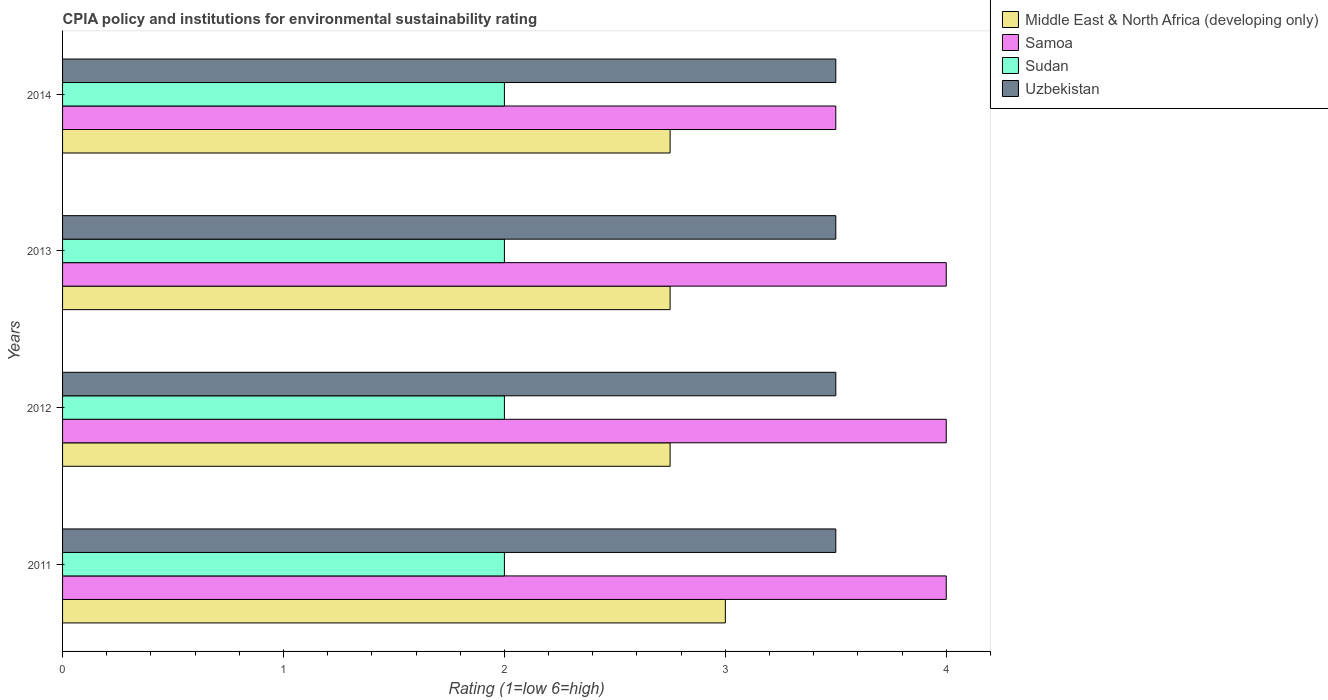How many different coloured bars are there?
Give a very brief answer. 4. In how many cases, is the number of bars for a given year not equal to the number of legend labels?
Offer a very short reply. 0. What is the CPIA rating in Samoa in 2014?
Provide a succinct answer. 3.5. Across all years, what is the maximum CPIA rating in Samoa?
Your response must be concise. 4. Across all years, what is the minimum CPIA rating in Middle East & North Africa (developing only)?
Provide a short and direct response. 2.75. In which year was the CPIA rating in Samoa maximum?
Offer a very short reply. 2011. In which year was the CPIA rating in Samoa minimum?
Provide a short and direct response. 2014. What is the total CPIA rating in Samoa in the graph?
Your response must be concise. 15.5. In the year 2014, what is the difference between the CPIA rating in Uzbekistan and CPIA rating in Middle East & North Africa (developing only)?
Your answer should be very brief. 0.75. What is the ratio of the CPIA rating in Middle East & North Africa (developing only) in 2012 to that in 2013?
Keep it short and to the point. 1. Is the difference between the CPIA rating in Uzbekistan in 2013 and 2014 greater than the difference between the CPIA rating in Middle East & North Africa (developing only) in 2013 and 2014?
Your answer should be very brief. No. In how many years, is the CPIA rating in Middle East & North Africa (developing only) greater than the average CPIA rating in Middle East & North Africa (developing only) taken over all years?
Offer a terse response. 1. Is the sum of the CPIA rating in Uzbekistan in 2011 and 2014 greater than the maximum CPIA rating in Samoa across all years?
Keep it short and to the point. Yes. What does the 1st bar from the top in 2012 represents?
Keep it short and to the point. Uzbekistan. What does the 2nd bar from the bottom in 2011 represents?
Give a very brief answer. Samoa. Are all the bars in the graph horizontal?
Offer a very short reply. Yes. What is the difference between two consecutive major ticks on the X-axis?
Make the answer very short. 1. Does the graph contain any zero values?
Provide a succinct answer. No. Does the graph contain grids?
Provide a short and direct response. No. How many legend labels are there?
Give a very brief answer. 4. What is the title of the graph?
Ensure brevity in your answer.  CPIA policy and institutions for environmental sustainability rating. Does "Singapore" appear as one of the legend labels in the graph?
Your response must be concise. No. What is the label or title of the X-axis?
Your answer should be compact. Rating (1=low 6=high). What is the label or title of the Y-axis?
Your answer should be compact. Years. What is the Rating (1=low 6=high) of Middle East & North Africa (developing only) in 2011?
Give a very brief answer. 3. What is the Rating (1=low 6=high) in Uzbekistan in 2011?
Ensure brevity in your answer.  3.5. What is the Rating (1=low 6=high) of Middle East & North Africa (developing only) in 2012?
Provide a succinct answer. 2.75. What is the Rating (1=low 6=high) of Samoa in 2012?
Offer a very short reply. 4. What is the Rating (1=low 6=high) of Sudan in 2012?
Your answer should be very brief. 2. What is the Rating (1=low 6=high) of Uzbekistan in 2012?
Your answer should be compact. 3.5. What is the Rating (1=low 6=high) in Middle East & North Africa (developing only) in 2013?
Keep it short and to the point. 2.75. What is the Rating (1=low 6=high) of Uzbekistan in 2013?
Your response must be concise. 3.5. What is the Rating (1=low 6=high) of Middle East & North Africa (developing only) in 2014?
Give a very brief answer. 2.75. What is the Rating (1=low 6=high) of Samoa in 2014?
Ensure brevity in your answer.  3.5. What is the Rating (1=low 6=high) in Sudan in 2014?
Ensure brevity in your answer.  2. Across all years, what is the maximum Rating (1=low 6=high) of Samoa?
Your answer should be very brief. 4. Across all years, what is the maximum Rating (1=low 6=high) in Sudan?
Your response must be concise. 2. Across all years, what is the minimum Rating (1=low 6=high) in Middle East & North Africa (developing only)?
Your answer should be compact. 2.75. Across all years, what is the minimum Rating (1=low 6=high) in Sudan?
Your answer should be very brief. 2. What is the total Rating (1=low 6=high) of Middle East & North Africa (developing only) in the graph?
Ensure brevity in your answer.  11.25. What is the total Rating (1=low 6=high) of Sudan in the graph?
Offer a very short reply. 8. What is the total Rating (1=low 6=high) of Uzbekistan in the graph?
Your answer should be very brief. 14. What is the difference between the Rating (1=low 6=high) of Middle East & North Africa (developing only) in 2011 and that in 2012?
Ensure brevity in your answer.  0.25. What is the difference between the Rating (1=low 6=high) in Sudan in 2011 and that in 2012?
Your response must be concise. 0. What is the difference between the Rating (1=low 6=high) of Middle East & North Africa (developing only) in 2011 and that in 2013?
Provide a short and direct response. 0.25. What is the difference between the Rating (1=low 6=high) in Samoa in 2011 and that in 2013?
Offer a very short reply. 0. What is the difference between the Rating (1=low 6=high) of Middle East & North Africa (developing only) in 2011 and that in 2014?
Offer a terse response. 0.25. What is the difference between the Rating (1=low 6=high) of Samoa in 2011 and that in 2014?
Provide a short and direct response. 0.5. What is the difference between the Rating (1=low 6=high) in Sudan in 2011 and that in 2014?
Give a very brief answer. 0. What is the difference between the Rating (1=low 6=high) of Uzbekistan in 2011 and that in 2014?
Give a very brief answer. 0. What is the difference between the Rating (1=low 6=high) in Middle East & North Africa (developing only) in 2012 and that in 2013?
Keep it short and to the point. 0. What is the difference between the Rating (1=low 6=high) in Samoa in 2012 and that in 2013?
Provide a succinct answer. 0. What is the difference between the Rating (1=low 6=high) in Sudan in 2012 and that in 2013?
Provide a succinct answer. 0. What is the difference between the Rating (1=low 6=high) of Middle East & North Africa (developing only) in 2012 and that in 2014?
Offer a very short reply. 0. What is the difference between the Rating (1=low 6=high) in Samoa in 2012 and that in 2014?
Offer a terse response. 0.5. What is the difference between the Rating (1=low 6=high) in Sudan in 2012 and that in 2014?
Your response must be concise. 0. What is the difference between the Rating (1=low 6=high) of Samoa in 2013 and that in 2014?
Your answer should be very brief. 0.5. What is the difference between the Rating (1=low 6=high) of Middle East & North Africa (developing only) in 2011 and the Rating (1=low 6=high) of Samoa in 2012?
Provide a short and direct response. -1. What is the difference between the Rating (1=low 6=high) in Middle East & North Africa (developing only) in 2011 and the Rating (1=low 6=high) in Uzbekistan in 2012?
Your response must be concise. -0.5. What is the difference between the Rating (1=low 6=high) of Sudan in 2011 and the Rating (1=low 6=high) of Uzbekistan in 2012?
Make the answer very short. -1.5. What is the difference between the Rating (1=low 6=high) in Middle East & North Africa (developing only) in 2011 and the Rating (1=low 6=high) in Samoa in 2013?
Offer a very short reply. -1. What is the difference between the Rating (1=low 6=high) of Samoa in 2011 and the Rating (1=low 6=high) of Sudan in 2013?
Provide a short and direct response. 2. What is the difference between the Rating (1=low 6=high) in Sudan in 2011 and the Rating (1=low 6=high) in Uzbekistan in 2013?
Make the answer very short. -1.5. What is the difference between the Rating (1=low 6=high) of Middle East & North Africa (developing only) in 2011 and the Rating (1=low 6=high) of Uzbekistan in 2014?
Your answer should be compact. -0.5. What is the difference between the Rating (1=low 6=high) of Samoa in 2011 and the Rating (1=low 6=high) of Sudan in 2014?
Keep it short and to the point. 2. What is the difference between the Rating (1=low 6=high) of Samoa in 2011 and the Rating (1=low 6=high) of Uzbekistan in 2014?
Make the answer very short. 0.5. What is the difference between the Rating (1=low 6=high) in Sudan in 2011 and the Rating (1=low 6=high) in Uzbekistan in 2014?
Your answer should be very brief. -1.5. What is the difference between the Rating (1=low 6=high) in Middle East & North Africa (developing only) in 2012 and the Rating (1=low 6=high) in Samoa in 2013?
Your response must be concise. -1.25. What is the difference between the Rating (1=low 6=high) of Middle East & North Africa (developing only) in 2012 and the Rating (1=low 6=high) of Uzbekistan in 2013?
Your answer should be compact. -0.75. What is the difference between the Rating (1=low 6=high) in Samoa in 2012 and the Rating (1=low 6=high) in Sudan in 2013?
Provide a succinct answer. 2. What is the difference between the Rating (1=low 6=high) of Middle East & North Africa (developing only) in 2012 and the Rating (1=low 6=high) of Samoa in 2014?
Your answer should be very brief. -0.75. What is the difference between the Rating (1=low 6=high) in Middle East & North Africa (developing only) in 2012 and the Rating (1=low 6=high) in Sudan in 2014?
Your answer should be very brief. 0.75. What is the difference between the Rating (1=low 6=high) in Middle East & North Africa (developing only) in 2012 and the Rating (1=low 6=high) in Uzbekistan in 2014?
Your answer should be very brief. -0.75. What is the difference between the Rating (1=low 6=high) in Sudan in 2012 and the Rating (1=low 6=high) in Uzbekistan in 2014?
Keep it short and to the point. -1.5. What is the difference between the Rating (1=low 6=high) of Middle East & North Africa (developing only) in 2013 and the Rating (1=low 6=high) of Samoa in 2014?
Offer a terse response. -0.75. What is the difference between the Rating (1=low 6=high) in Middle East & North Africa (developing only) in 2013 and the Rating (1=low 6=high) in Sudan in 2014?
Keep it short and to the point. 0.75. What is the difference between the Rating (1=low 6=high) of Middle East & North Africa (developing only) in 2013 and the Rating (1=low 6=high) of Uzbekistan in 2014?
Provide a succinct answer. -0.75. What is the difference between the Rating (1=low 6=high) in Samoa in 2013 and the Rating (1=low 6=high) in Sudan in 2014?
Give a very brief answer. 2. What is the average Rating (1=low 6=high) in Middle East & North Africa (developing only) per year?
Provide a short and direct response. 2.81. What is the average Rating (1=low 6=high) of Samoa per year?
Offer a terse response. 3.88. In the year 2011, what is the difference between the Rating (1=low 6=high) of Middle East & North Africa (developing only) and Rating (1=low 6=high) of Samoa?
Your answer should be very brief. -1. In the year 2011, what is the difference between the Rating (1=low 6=high) of Middle East & North Africa (developing only) and Rating (1=low 6=high) of Sudan?
Make the answer very short. 1. In the year 2011, what is the difference between the Rating (1=low 6=high) of Middle East & North Africa (developing only) and Rating (1=low 6=high) of Uzbekistan?
Provide a succinct answer. -0.5. In the year 2011, what is the difference between the Rating (1=low 6=high) of Samoa and Rating (1=low 6=high) of Sudan?
Ensure brevity in your answer.  2. In the year 2012, what is the difference between the Rating (1=low 6=high) in Middle East & North Africa (developing only) and Rating (1=low 6=high) in Samoa?
Your answer should be very brief. -1.25. In the year 2012, what is the difference between the Rating (1=low 6=high) of Middle East & North Africa (developing only) and Rating (1=low 6=high) of Sudan?
Ensure brevity in your answer.  0.75. In the year 2012, what is the difference between the Rating (1=low 6=high) in Middle East & North Africa (developing only) and Rating (1=low 6=high) in Uzbekistan?
Give a very brief answer. -0.75. In the year 2012, what is the difference between the Rating (1=low 6=high) in Sudan and Rating (1=low 6=high) in Uzbekistan?
Your response must be concise. -1.5. In the year 2013, what is the difference between the Rating (1=low 6=high) of Middle East & North Africa (developing only) and Rating (1=low 6=high) of Samoa?
Give a very brief answer. -1.25. In the year 2013, what is the difference between the Rating (1=low 6=high) of Middle East & North Africa (developing only) and Rating (1=low 6=high) of Uzbekistan?
Your answer should be compact. -0.75. In the year 2013, what is the difference between the Rating (1=low 6=high) in Samoa and Rating (1=low 6=high) in Uzbekistan?
Offer a terse response. 0.5. In the year 2014, what is the difference between the Rating (1=low 6=high) of Middle East & North Africa (developing only) and Rating (1=low 6=high) of Samoa?
Offer a terse response. -0.75. In the year 2014, what is the difference between the Rating (1=low 6=high) in Middle East & North Africa (developing only) and Rating (1=low 6=high) in Uzbekistan?
Offer a terse response. -0.75. What is the ratio of the Rating (1=low 6=high) of Middle East & North Africa (developing only) in 2011 to that in 2012?
Keep it short and to the point. 1.09. What is the ratio of the Rating (1=low 6=high) of Sudan in 2011 to that in 2012?
Your answer should be compact. 1. What is the ratio of the Rating (1=low 6=high) of Uzbekistan in 2011 to that in 2012?
Your response must be concise. 1. What is the ratio of the Rating (1=low 6=high) of Middle East & North Africa (developing only) in 2011 to that in 2013?
Your response must be concise. 1.09. What is the ratio of the Rating (1=low 6=high) of Samoa in 2011 to that in 2013?
Your response must be concise. 1. What is the ratio of the Rating (1=low 6=high) in Sudan in 2011 to that in 2013?
Give a very brief answer. 1. What is the ratio of the Rating (1=low 6=high) in Middle East & North Africa (developing only) in 2011 to that in 2014?
Your answer should be compact. 1.09. What is the ratio of the Rating (1=low 6=high) of Sudan in 2011 to that in 2014?
Give a very brief answer. 1. What is the ratio of the Rating (1=low 6=high) of Middle East & North Africa (developing only) in 2012 to that in 2013?
Make the answer very short. 1. What is the ratio of the Rating (1=low 6=high) in Samoa in 2012 to that in 2013?
Offer a terse response. 1. What is the ratio of the Rating (1=low 6=high) in Uzbekistan in 2012 to that in 2013?
Offer a very short reply. 1. What is the ratio of the Rating (1=low 6=high) of Uzbekistan in 2012 to that in 2014?
Provide a succinct answer. 1. What is the ratio of the Rating (1=low 6=high) of Samoa in 2013 to that in 2014?
Offer a terse response. 1.14. What is the difference between the highest and the second highest Rating (1=low 6=high) in Middle East & North Africa (developing only)?
Offer a terse response. 0.25. What is the difference between the highest and the second highest Rating (1=low 6=high) of Samoa?
Your answer should be very brief. 0. What is the difference between the highest and the second highest Rating (1=low 6=high) of Uzbekistan?
Provide a succinct answer. 0. What is the difference between the highest and the lowest Rating (1=low 6=high) in Middle East & North Africa (developing only)?
Provide a short and direct response. 0.25. What is the difference between the highest and the lowest Rating (1=low 6=high) of Sudan?
Ensure brevity in your answer.  0. What is the difference between the highest and the lowest Rating (1=low 6=high) in Uzbekistan?
Provide a short and direct response. 0. 